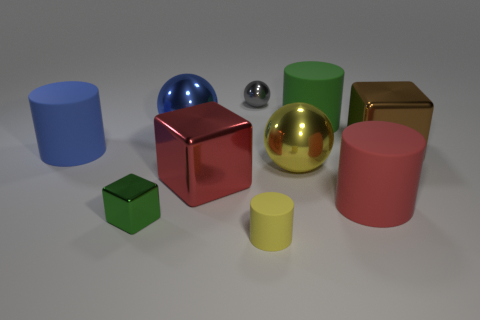The brown object is what shape?
Offer a very short reply. Cube. Is the blue ball made of the same material as the green thing that is on the left side of the yellow ball?
Provide a succinct answer. Yes. What number of objects are either yellow metallic objects or large blocks?
Provide a succinct answer. 3. Is there a large red metal block?
Your answer should be compact. Yes. The green object that is in front of the large ball in front of the big brown metal thing is what shape?
Make the answer very short. Cube. How many things are either large blue objects in front of the small metallic ball or cubes right of the small metal block?
Ensure brevity in your answer.  4. There is a yellow object that is the same size as the red metal block; what is its material?
Make the answer very short. Metal. The tiny rubber object has what color?
Your answer should be compact. Yellow. There is a large thing that is both left of the tiny ball and in front of the large blue cylinder; what material is it made of?
Make the answer very short. Metal. There is a large metallic ball that is left of the tiny metallic thing behind the large brown metal block; are there any large green objects that are in front of it?
Ensure brevity in your answer.  No. 